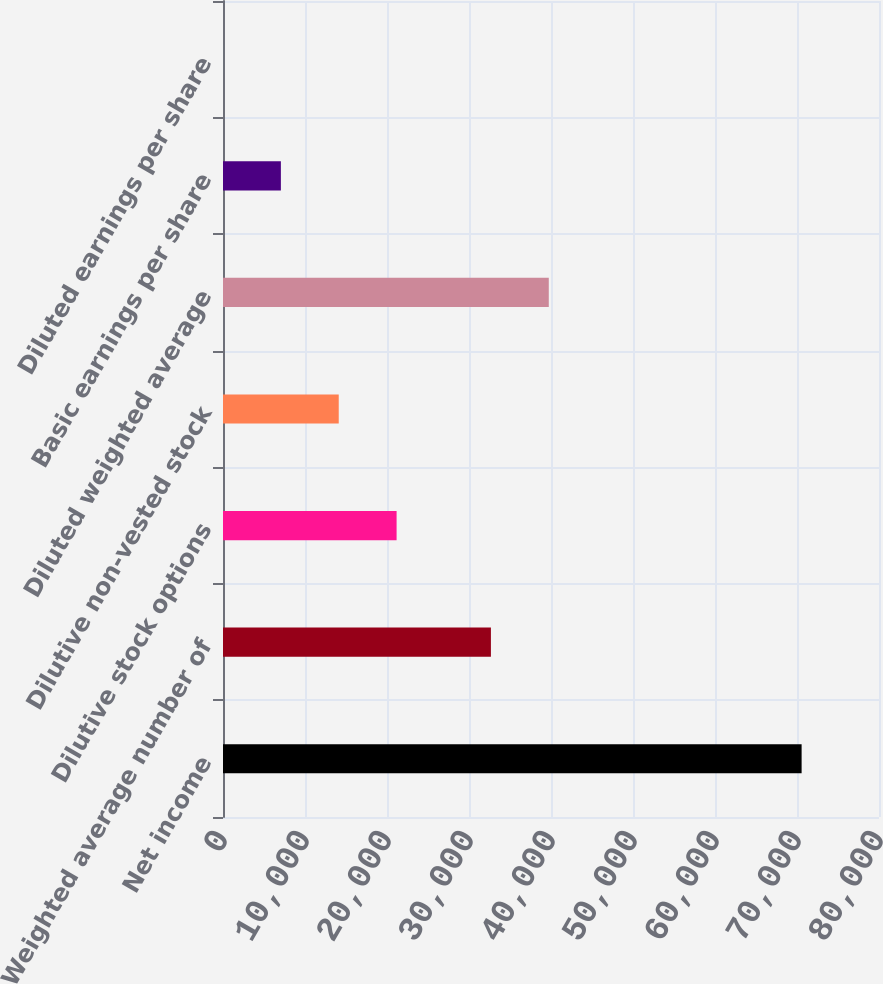Convert chart. <chart><loc_0><loc_0><loc_500><loc_500><bar_chart><fcel>Net income<fcel>Weighted average number of<fcel>Dilutive stock options<fcel>Dilutive non-vested stock<fcel>Diluted weighted average<fcel>Basic earnings per share<fcel>Diluted earnings per share<nl><fcel>70563<fcel>32672<fcel>21170.4<fcel>14114.3<fcel>39728.1<fcel>7058.22<fcel>2.13<nl></chart> 